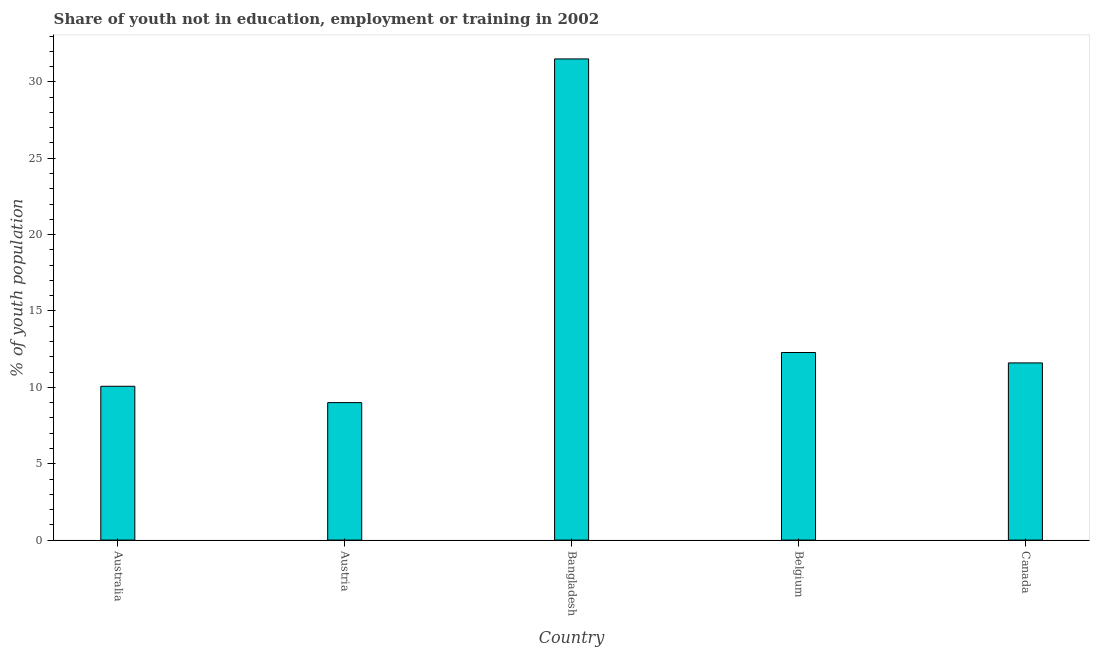Does the graph contain any zero values?
Your answer should be very brief. No. Does the graph contain grids?
Make the answer very short. No. What is the title of the graph?
Keep it short and to the point. Share of youth not in education, employment or training in 2002. What is the label or title of the Y-axis?
Keep it short and to the point. % of youth population. What is the unemployed youth population in Austria?
Provide a succinct answer. 9. Across all countries, what is the maximum unemployed youth population?
Provide a succinct answer. 31.5. In which country was the unemployed youth population maximum?
Your answer should be compact. Bangladesh. What is the sum of the unemployed youth population?
Ensure brevity in your answer.  74.45. What is the difference between the unemployed youth population in Bangladesh and Belgium?
Make the answer very short. 19.22. What is the average unemployed youth population per country?
Provide a short and direct response. 14.89. What is the median unemployed youth population?
Keep it short and to the point. 11.6. In how many countries, is the unemployed youth population greater than 7 %?
Make the answer very short. 5. What is the ratio of the unemployed youth population in Austria to that in Bangladesh?
Offer a terse response. 0.29. Is the unemployed youth population in Bangladesh less than that in Canada?
Make the answer very short. No. Is the difference between the unemployed youth population in Bangladesh and Canada greater than the difference between any two countries?
Offer a very short reply. No. What is the difference between the highest and the second highest unemployed youth population?
Give a very brief answer. 19.22. Is the sum of the unemployed youth population in Australia and Bangladesh greater than the maximum unemployed youth population across all countries?
Make the answer very short. Yes. What is the difference between the highest and the lowest unemployed youth population?
Provide a short and direct response. 22.5. In how many countries, is the unemployed youth population greater than the average unemployed youth population taken over all countries?
Give a very brief answer. 1. What is the difference between two consecutive major ticks on the Y-axis?
Give a very brief answer. 5. What is the % of youth population in Australia?
Offer a very short reply. 10.07. What is the % of youth population of Bangladesh?
Your answer should be very brief. 31.5. What is the % of youth population of Belgium?
Give a very brief answer. 12.28. What is the % of youth population in Canada?
Your answer should be very brief. 11.6. What is the difference between the % of youth population in Australia and Austria?
Provide a short and direct response. 1.07. What is the difference between the % of youth population in Australia and Bangladesh?
Your answer should be very brief. -21.43. What is the difference between the % of youth population in Australia and Belgium?
Your answer should be very brief. -2.21. What is the difference between the % of youth population in Australia and Canada?
Offer a very short reply. -1.53. What is the difference between the % of youth population in Austria and Bangladesh?
Give a very brief answer. -22.5. What is the difference between the % of youth population in Austria and Belgium?
Your answer should be compact. -3.28. What is the difference between the % of youth population in Bangladesh and Belgium?
Offer a very short reply. 19.22. What is the difference between the % of youth population in Belgium and Canada?
Your answer should be very brief. 0.68. What is the ratio of the % of youth population in Australia to that in Austria?
Provide a succinct answer. 1.12. What is the ratio of the % of youth population in Australia to that in Bangladesh?
Your answer should be very brief. 0.32. What is the ratio of the % of youth population in Australia to that in Belgium?
Make the answer very short. 0.82. What is the ratio of the % of youth population in Australia to that in Canada?
Make the answer very short. 0.87. What is the ratio of the % of youth population in Austria to that in Bangladesh?
Provide a succinct answer. 0.29. What is the ratio of the % of youth population in Austria to that in Belgium?
Your response must be concise. 0.73. What is the ratio of the % of youth population in Austria to that in Canada?
Provide a succinct answer. 0.78. What is the ratio of the % of youth population in Bangladesh to that in Belgium?
Your response must be concise. 2.56. What is the ratio of the % of youth population in Bangladesh to that in Canada?
Provide a succinct answer. 2.72. What is the ratio of the % of youth population in Belgium to that in Canada?
Provide a short and direct response. 1.06. 